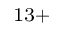<formula> <loc_0><loc_0><loc_500><loc_500>^ { 1 3 + }</formula> 